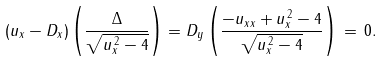<formula> <loc_0><loc_0><loc_500><loc_500>( u _ { x } - D _ { x } ) \left ( \frac { \Delta } { \sqrt { u _ { x } ^ { \, 2 } - 4 } } \right ) = D _ { y } \left ( \frac { - u _ { x x } + u _ { x } ^ { \, 2 } - 4 } { \sqrt { u _ { x } ^ { \, 2 } - 4 } } \right ) \, = \, 0 .</formula> 